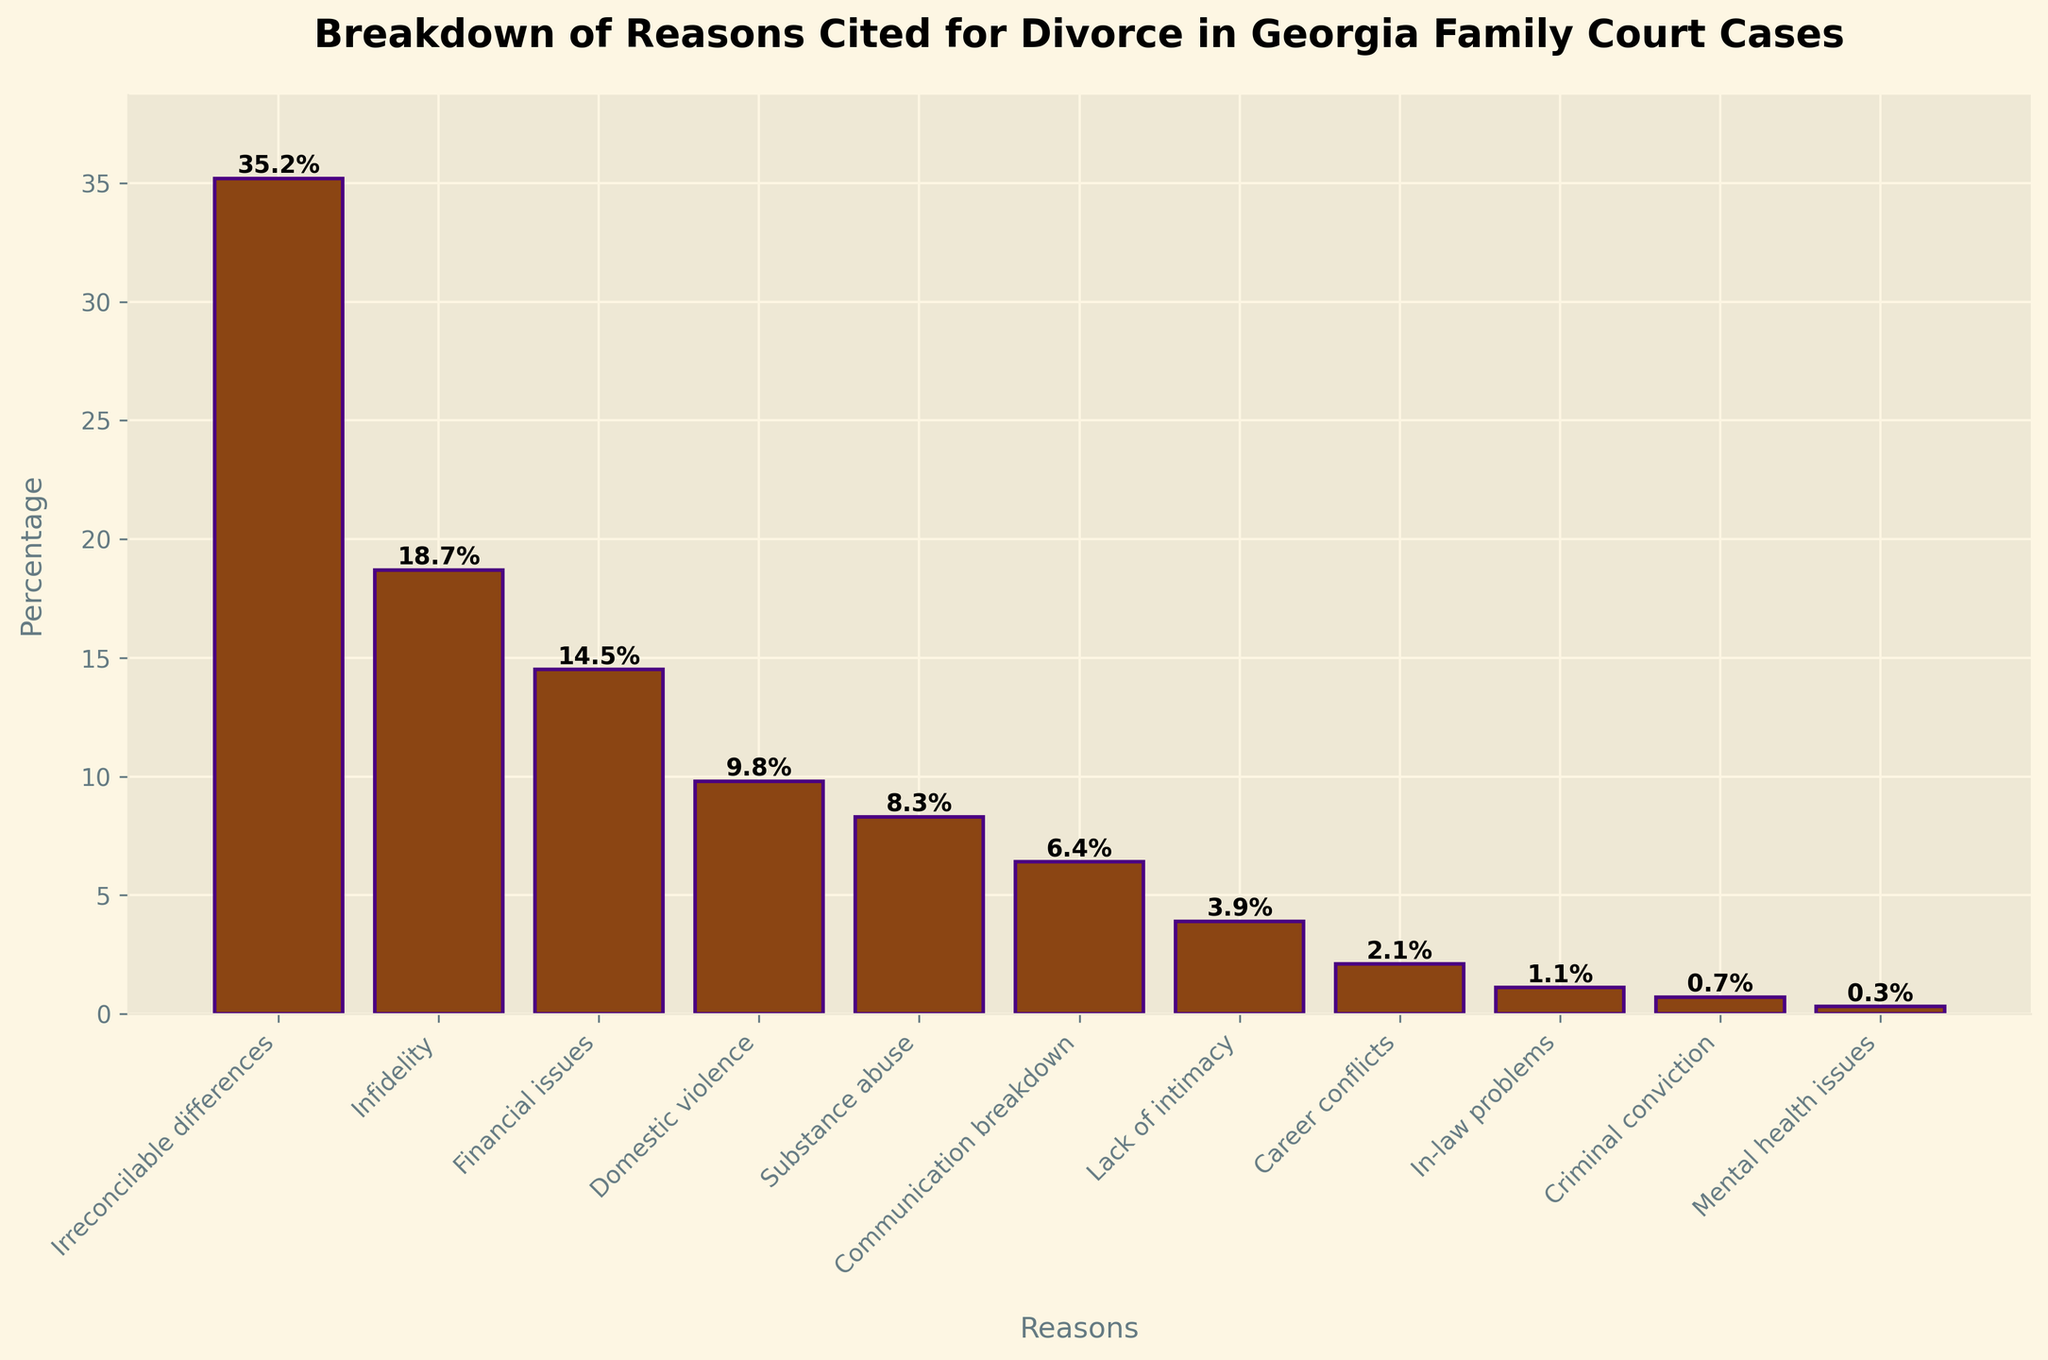What's the most frequently cited reason for divorce in Georgia family court cases? The bar with the greatest height represents the most frequently cited reason. By observing the heights, "Irreconcilable differences" is the tallest bar.
Answer: Irreconcilable differences Which reason has the smallest percentage cited for divorce? The shortest bar indicates the reason with the smallest percentage. "Mental health issues" is the shortest bar.
Answer: Mental health issues How much more frequently is "Infidelity" cited compared to "Substance abuse"? Find the heights of the bars for "Infidelity" and "Substance abuse" and subtract the latter from the former: 18.7% - 8.3% = 10.4%.
Answer: 10.4% What are the three least cited reasons for divorce? Identify the three shortest bars: "Criminal conviction", "In-law problems", and "Mental health issues".
Answer: Criminal conviction, In-law problems, Mental health issues Which reason has a higher percentage: "Communication breakdown" or "Lack of intimacy"? Compare the heights of the bars for "Communication breakdown" and "Lack of intimacy". "Communication breakdown" is taller than "Lack of intimacy".
Answer: Communication breakdown What is the combined percentage of divorces citing "Domestic violence" and "Career conflicts"? Add the percentages of "Domestic violence" (9.8%) and "Career conflicts" (2.1%): 9.8% + 2.1% = 11.9%.
Answer: 11.9% How does the percentage of divorces due to "Financial issues" compare to the average percentage of the top three reasons? Identify the top three reasons and calculate their average:
(35.2% + 18.7% + 14.5%) / 3 = 22.8%. Compare this with "Financial issues" (14.5%). 14.5% is less than 22.8%.
Answer: Less Is "Substance abuse" cited more often than "Domestic violence"? Compare the heights of the bars for "Substance abuse" (8.3%) and "Domestic violence" (9.8%). "Domestic violence" is taller.
Answer: No What percentage of divorces cite "Irreconcilable differences"? Look for the "Irreconcilable differences" bar and read its value, which is also labeled at the top of its bar: 35.2%.
Answer: 35.2% What visual features distinguish the bars on the chart? The bars differ in heights, reflecting different percentages. They are colored dark brown with purple edges.
Answer: Heights and colors 